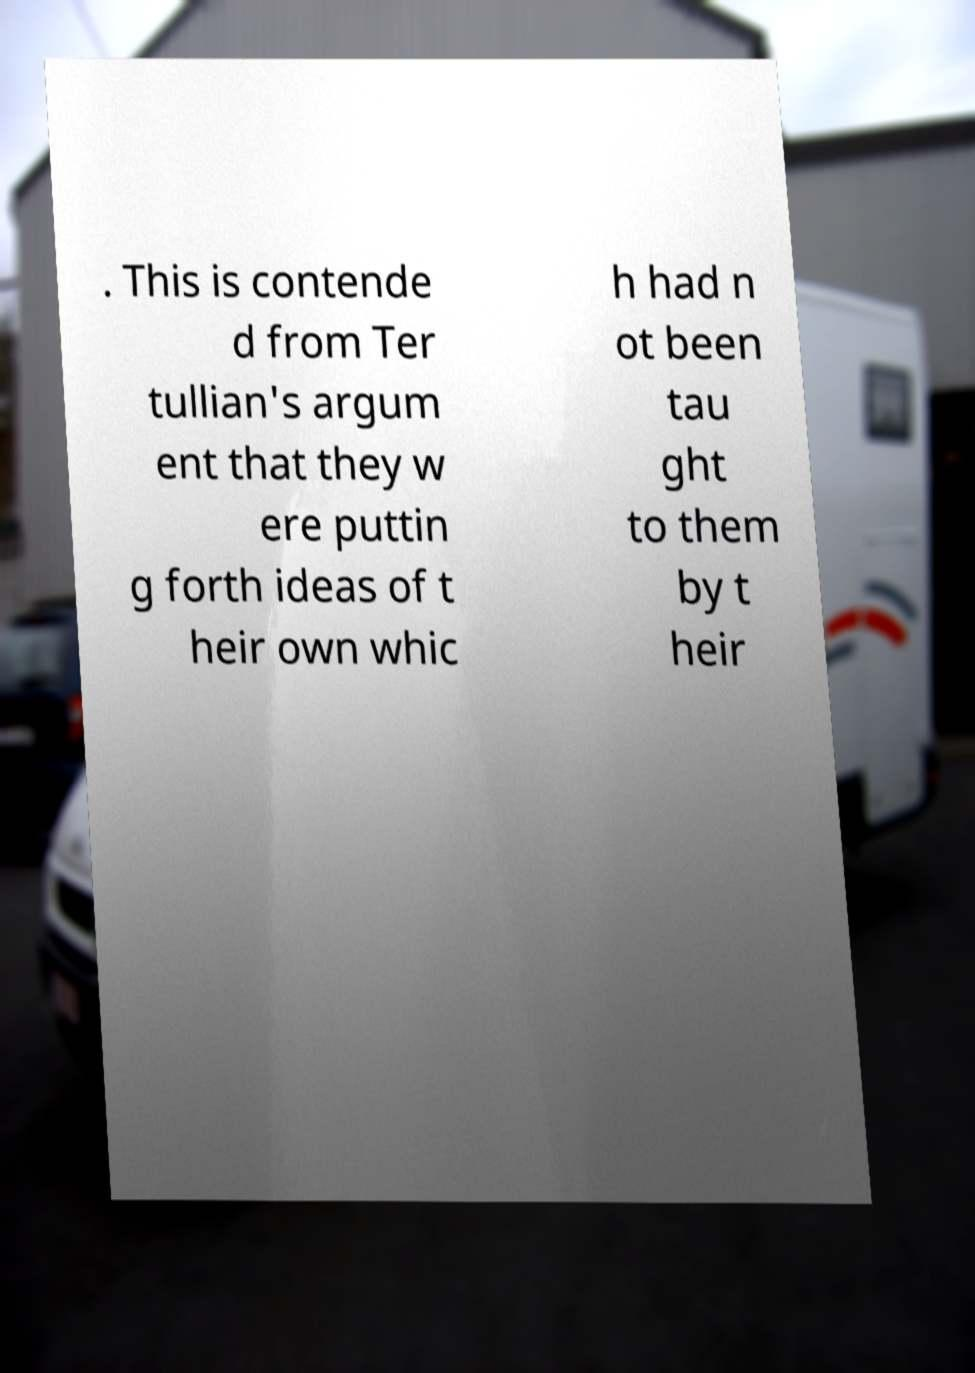Can you read and provide the text displayed in the image?This photo seems to have some interesting text. Can you extract and type it out for me? . This is contende d from Ter tullian's argum ent that they w ere puttin g forth ideas of t heir own whic h had n ot been tau ght to them by t heir 